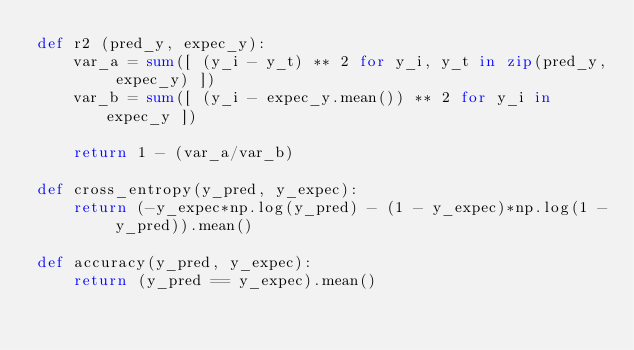Convert code to text. <code><loc_0><loc_0><loc_500><loc_500><_Python_>def r2 (pred_y, expec_y):
    var_a = sum([ (y_i - y_t) ** 2 for y_i, y_t in zip(pred_y, expec_y) ])
    var_b = sum([ (y_i - expec_y.mean()) ** 2 for y_i in expec_y ])
        
    return 1 - (var_a/var_b)

def cross_entropy(y_pred, y_expec):
    return (-y_expec*np.log(y_pred) - (1 - y_expec)*np.log(1 - y_pred)).mean()

def accuracy(y_pred, y_expec):
    return (y_pred == y_expec).mean()</code> 